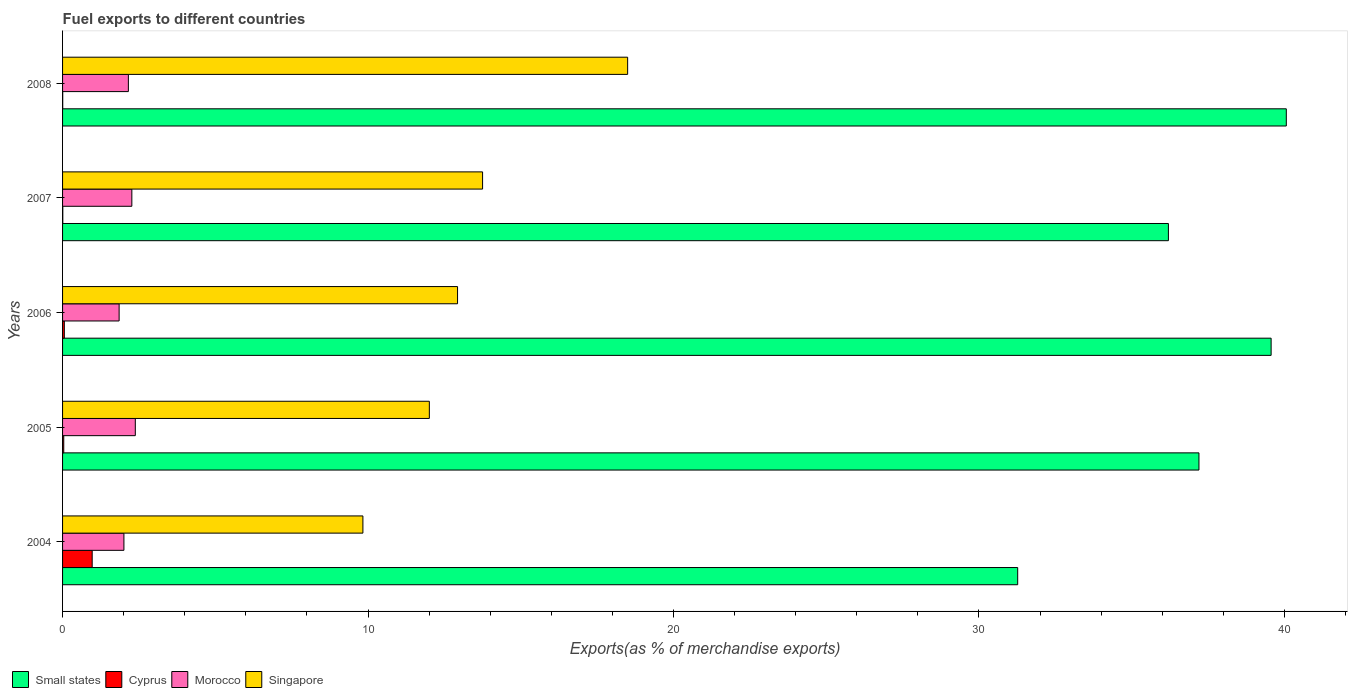How many bars are there on the 2nd tick from the top?
Offer a very short reply. 4. How many bars are there on the 5th tick from the bottom?
Make the answer very short. 4. In how many cases, is the number of bars for a given year not equal to the number of legend labels?
Your answer should be compact. 0. What is the percentage of exports to different countries in Singapore in 2006?
Provide a succinct answer. 12.93. Across all years, what is the maximum percentage of exports to different countries in Small states?
Give a very brief answer. 40.06. Across all years, what is the minimum percentage of exports to different countries in Cyprus?
Offer a terse response. 0. In which year was the percentage of exports to different countries in Morocco maximum?
Offer a terse response. 2005. What is the total percentage of exports to different countries in Cyprus in the graph?
Your answer should be very brief. 1.08. What is the difference between the percentage of exports to different countries in Morocco in 2004 and that in 2006?
Keep it short and to the point. 0.16. What is the difference between the percentage of exports to different countries in Cyprus in 2006 and the percentage of exports to different countries in Morocco in 2007?
Ensure brevity in your answer.  -2.21. What is the average percentage of exports to different countries in Cyprus per year?
Provide a short and direct response. 0.22. In the year 2006, what is the difference between the percentage of exports to different countries in Singapore and percentage of exports to different countries in Small states?
Your answer should be very brief. -26.63. In how many years, is the percentage of exports to different countries in Morocco greater than 38 %?
Give a very brief answer. 0. What is the ratio of the percentage of exports to different countries in Cyprus in 2004 to that in 2005?
Keep it short and to the point. 25.09. Is the difference between the percentage of exports to different countries in Singapore in 2004 and 2008 greater than the difference between the percentage of exports to different countries in Small states in 2004 and 2008?
Ensure brevity in your answer.  Yes. What is the difference between the highest and the second highest percentage of exports to different countries in Morocco?
Your response must be concise. 0.11. What is the difference between the highest and the lowest percentage of exports to different countries in Small states?
Provide a short and direct response. 8.79. In how many years, is the percentage of exports to different countries in Singapore greater than the average percentage of exports to different countries in Singapore taken over all years?
Give a very brief answer. 2. Is the sum of the percentage of exports to different countries in Small states in 2006 and 2007 greater than the maximum percentage of exports to different countries in Singapore across all years?
Give a very brief answer. Yes. Is it the case that in every year, the sum of the percentage of exports to different countries in Morocco and percentage of exports to different countries in Cyprus is greater than the sum of percentage of exports to different countries in Small states and percentage of exports to different countries in Singapore?
Offer a terse response. No. What does the 3rd bar from the top in 2006 represents?
Offer a terse response. Cyprus. What does the 2nd bar from the bottom in 2005 represents?
Offer a terse response. Cyprus. How many bars are there?
Keep it short and to the point. 20. Are the values on the major ticks of X-axis written in scientific E-notation?
Your answer should be compact. No. Where does the legend appear in the graph?
Make the answer very short. Bottom left. How many legend labels are there?
Provide a succinct answer. 4. What is the title of the graph?
Keep it short and to the point. Fuel exports to different countries. Does "Heavily indebted poor countries" appear as one of the legend labels in the graph?
Your answer should be compact. No. What is the label or title of the X-axis?
Offer a terse response. Exports(as % of merchandise exports). What is the label or title of the Y-axis?
Offer a very short reply. Years. What is the Exports(as % of merchandise exports) of Small states in 2004?
Provide a short and direct response. 31.27. What is the Exports(as % of merchandise exports) in Cyprus in 2004?
Your answer should be compact. 0.97. What is the Exports(as % of merchandise exports) in Morocco in 2004?
Provide a succinct answer. 2.01. What is the Exports(as % of merchandise exports) in Singapore in 2004?
Make the answer very short. 9.83. What is the Exports(as % of merchandise exports) in Small states in 2005?
Your answer should be very brief. 37.2. What is the Exports(as % of merchandise exports) of Cyprus in 2005?
Your answer should be very brief. 0.04. What is the Exports(as % of merchandise exports) of Morocco in 2005?
Your response must be concise. 2.38. What is the Exports(as % of merchandise exports) in Singapore in 2005?
Your answer should be compact. 12.01. What is the Exports(as % of merchandise exports) in Small states in 2006?
Your answer should be very brief. 39.56. What is the Exports(as % of merchandise exports) of Cyprus in 2006?
Provide a succinct answer. 0.06. What is the Exports(as % of merchandise exports) in Morocco in 2006?
Ensure brevity in your answer.  1.85. What is the Exports(as % of merchandise exports) in Singapore in 2006?
Your answer should be compact. 12.93. What is the Exports(as % of merchandise exports) of Small states in 2007?
Keep it short and to the point. 36.2. What is the Exports(as % of merchandise exports) in Cyprus in 2007?
Offer a very short reply. 0.01. What is the Exports(as % of merchandise exports) of Morocco in 2007?
Provide a succinct answer. 2.27. What is the Exports(as % of merchandise exports) of Singapore in 2007?
Ensure brevity in your answer.  13.75. What is the Exports(as % of merchandise exports) in Small states in 2008?
Your answer should be very brief. 40.06. What is the Exports(as % of merchandise exports) in Cyprus in 2008?
Your response must be concise. 0. What is the Exports(as % of merchandise exports) of Morocco in 2008?
Provide a short and direct response. 2.15. What is the Exports(as % of merchandise exports) of Singapore in 2008?
Provide a succinct answer. 18.5. Across all years, what is the maximum Exports(as % of merchandise exports) in Small states?
Your response must be concise. 40.06. Across all years, what is the maximum Exports(as % of merchandise exports) of Cyprus?
Make the answer very short. 0.97. Across all years, what is the maximum Exports(as % of merchandise exports) in Morocco?
Provide a short and direct response. 2.38. Across all years, what is the maximum Exports(as % of merchandise exports) of Singapore?
Provide a succinct answer. 18.5. Across all years, what is the minimum Exports(as % of merchandise exports) in Small states?
Your answer should be compact. 31.27. Across all years, what is the minimum Exports(as % of merchandise exports) of Cyprus?
Make the answer very short. 0. Across all years, what is the minimum Exports(as % of merchandise exports) in Morocco?
Keep it short and to the point. 1.85. Across all years, what is the minimum Exports(as % of merchandise exports) of Singapore?
Offer a very short reply. 9.83. What is the total Exports(as % of merchandise exports) of Small states in the graph?
Make the answer very short. 184.29. What is the total Exports(as % of merchandise exports) of Cyprus in the graph?
Offer a very short reply. 1.08. What is the total Exports(as % of merchandise exports) in Morocco in the graph?
Offer a terse response. 10.66. What is the total Exports(as % of merchandise exports) of Singapore in the graph?
Provide a succinct answer. 67.02. What is the difference between the Exports(as % of merchandise exports) of Small states in 2004 and that in 2005?
Provide a succinct answer. -5.93. What is the difference between the Exports(as % of merchandise exports) in Morocco in 2004 and that in 2005?
Your answer should be very brief. -0.37. What is the difference between the Exports(as % of merchandise exports) in Singapore in 2004 and that in 2005?
Your response must be concise. -2.17. What is the difference between the Exports(as % of merchandise exports) of Small states in 2004 and that in 2006?
Your answer should be compact. -8.3. What is the difference between the Exports(as % of merchandise exports) in Cyprus in 2004 and that in 2006?
Your answer should be compact. 0.91. What is the difference between the Exports(as % of merchandise exports) of Morocco in 2004 and that in 2006?
Provide a succinct answer. 0.16. What is the difference between the Exports(as % of merchandise exports) of Singapore in 2004 and that in 2006?
Provide a short and direct response. -3.1. What is the difference between the Exports(as % of merchandise exports) of Small states in 2004 and that in 2007?
Your response must be concise. -4.93. What is the difference between the Exports(as % of merchandise exports) in Cyprus in 2004 and that in 2007?
Provide a succinct answer. 0.96. What is the difference between the Exports(as % of merchandise exports) of Morocco in 2004 and that in 2007?
Your answer should be compact. -0.26. What is the difference between the Exports(as % of merchandise exports) in Singapore in 2004 and that in 2007?
Give a very brief answer. -3.92. What is the difference between the Exports(as % of merchandise exports) of Small states in 2004 and that in 2008?
Provide a succinct answer. -8.79. What is the difference between the Exports(as % of merchandise exports) of Cyprus in 2004 and that in 2008?
Keep it short and to the point. 0.96. What is the difference between the Exports(as % of merchandise exports) of Morocco in 2004 and that in 2008?
Provide a short and direct response. -0.15. What is the difference between the Exports(as % of merchandise exports) of Singapore in 2004 and that in 2008?
Your response must be concise. -8.67. What is the difference between the Exports(as % of merchandise exports) of Small states in 2005 and that in 2006?
Offer a terse response. -2.36. What is the difference between the Exports(as % of merchandise exports) in Cyprus in 2005 and that in 2006?
Provide a succinct answer. -0.02. What is the difference between the Exports(as % of merchandise exports) of Morocco in 2005 and that in 2006?
Keep it short and to the point. 0.53. What is the difference between the Exports(as % of merchandise exports) of Singapore in 2005 and that in 2006?
Ensure brevity in your answer.  -0.92. What is the difference between the Exports(as % of merchandise exports) in Small states in 2005 and that in 2007?
Offer a very short reply. 1. What is the difference between the Exports(as % of merchandise exports) of Cyprus in 2005 and that in 2007?
Provide a succinct answer. 0.03. What is the difference between the Exports(as % of merchandise exports) in Morocco in 2005 and that in 2007?
Your answer should be very brief. 0.11. What is the difference between the Exports(as % of merchandise exports) in Singapore in 2005 and that in 2007?
Ensure brevity in your answer.  -1.74. What is the difference between the Exports(as % of merchandise exports) of Small states in 2005 and that in 2008?
Keep it short and to the point. -2.86. What is the difference between the Exports(as % of merchandise exports) of Cyprus in 2005 and that in 2008?
Your answer should be compact. 0.03. What is the difference between the Exports(as % of merchandise exports) of Morocco in 2005 and that in 2008?
Your response must be concise. 0.23. What is the difference between the Exports(as % of merchandise exports) in Singapore in 2005 and that in 2008?
Your answer should be compact. -6.49. What is the difference between the Exports(as % of merchandise exports) of Small states in 2006 and that in 2007?
Make the answer very short. 3.36. What is the difference between the Exports(as % of merchandise exports) of Cyprus in 2006 and that in 2007?
Ensure brevity in your answer.  0.05. What is the difference between the Exports(as % of merchandise exports) in Morocco in 2006 and that in 2007?
Your answer should be very brief. -0.42. What is the difference between the Exports(as % of merchandise exports) in Singapore in 2006 and that in 2007?
Offer a very short reply. -0.82. What is the difference between the Exports(as % of merchandise exports) of Small states in 2006 and that in 2008?
Give a very brief answer. -0.5. What is the difference between the Exports(as % of merchandise exports) in Cyprus in 2006 and that in 2008?
Give a very brief answer. 0.05. What is the difference between the Exports(as % of merchandise exports) in Morocco in 2006 and that in 2008?
Make the answer very short. -0.3. What is the difference between the Exports(as % of merchandise exports) of Singapore in 2006 and that in 2008?
Your answer should be compact. -5.57. What is the difference between the Exports(as % of merchandise exports) of Small states in 2007 and that in 2008?
Provide a short and direct response. -3.86. What is the difference between the Exports(as % of merchandise exports) in Cyprus in 2007 and that in 2008?
Ensure brevity in your answer.  0. What is the difference between the Exports(as % of merchandise exports) in Morocco in 2007 and that in 2008?
Provide a short and direct response. 0.11. What is the difference between the Exports(as % of merchandise exports) of Singapore in 2007 and that in 2008?
Your answer should be very brief. -4.75. What is the difference between the Exports(as % of merchandise exports) in Small states in 2004 and the Exports(as % of merchandise exports) in Cyprus in 2005?
Ensure brevity in your answer.  31.23. What is the difference between the Exports(as % of merchandise exports) of Small states in 2004 and the Exports(as % of merchandise exports) of Morocco in 2005?
Provide a short and direct response. 28.89. What is the difference between the Exports(as % of merchandise exports) of Small states in 2004 and the Exports(as % of merchandise exports) of Singapore in 2005?
Ensure brevity in your answer.  19.26. What is the difference between the Exports(as % of merchandise exports) in Cyprus in 2004 and the Exports(as % of merchandise exports) in Morocco in 2005?
Make the answer very short. -1.41. What is the difference between the Exports(as % of merchandise exports) of Cyprus in 2004 and the Exports(as % of merchandise exports) of Singapore in 2005?
Your answer should be compact. -11.04. What is the difference between the Exports(as % of merchandise exports) in Morocco in 2004 and the Exports(as % of merchandise exports) in Singapore in 2005?
Make the answer very short. -10. What is the difference between the Exports(as % of merchandise exports) in Small states in 2004 and the Exports(as % of merchandise exports) in Cyprus in 2006?
Your response must be concise. 31.21. What is the difference between the Exports(as % of merchandise exports) in Small states in 2004 and the Exports(as % of merchandise exports) in Morocco in 2006?
Make the answer very short. 29.42. What is the difference between the Exports(as % of merchandise exports) of Small states in 2004 and the Exports(as % of merchandise exports) of Singapore in 2006?
Ensure brevity in your answer.  18.34. What is the difference between the Exports(as % of merchandise exports) in Cyprus in 2004 and the Exports(as % of merchandise exports) in Morocco in 2006?
Your answer should be very brief. -0.88. What is the difference between the Exports(as % of merchandise exports) in Cyprus in 2004 and the Exports(as % of merchandise exports) in Singapore in 2006?
Your answer should be very brief. -11.96. What is the difference between the Exports(as % of merchandise exports) in Morocco in 2004 and the Exports(as % of merchandise exports) in Singapore in 2006?
Your answer should be compact. -10.92. What is the difference between the Exports(as % of merchandise exports) in Small states in 2004 and the Exports(as % of merchandise exports) in Cyprus in 2007?
Keep it short and to the point. 31.26. What is the difference between the Exports(as % of merchandise exports) of Small states in 2004 and the Exports(as % of merchandise exports) of Morocco in 2007?
Offer a very short reply. 29. What is the difference between the Exports(as % of merchandise exports) of Small states in 2004 and the Exports(as % of merchandise exports) of Singapore in 2007?
Keep it short and to the point. 17.52. What is the difference between the Exports(as % of merchandise exports) of Cyprus in 2004 and the Exports(as % of merchandise exports) of Morocco in 2007?
Provide a short and direct response. -1.3. What is the difference between the Exports(as % of merchandise exports) in Cyprus in 2004 and the Exports(as % of merchandise exports) in Singapore in 2007?
Ensure brevity in your answer.  -12.78. What is the difference between the Exports(as % of merchandise exports) in Morocco in 2004 and the Exports(as % of merchandise exports) in Singapore in 2007?
Your answer should be compact. -11.74. What is the difference between the Exports(as % of merchandise exports) of Small states in 2004 and the Exports(as % of merchandise exports) of Cyprus in 2008?
Your response must be concise. 31.26. What is the difference between the Exports(as % of merchandise exports) of Small states in 2004 and the Exports(as % of merchandise exports) of Morocco in 2008?
Your answer should be compact. 29.11. What is the difference between the Exports(as % of merchandise exports) in Small states in 2004 and the Exports(as % of merchandise exports) in Singapore in 2008?
Keep it short and to the point. 12.77. What is the difference between the Exports(as % of merchandise exports) of Cyprus in 2004 and the Exports(as % of merchandise exports) of Morocco in 2008?
Ensure brevity in your answer.  -1.18. What is the difference between the Exports(as % of merchandise exports) of Cyprus in 2004 and the Exports(as % of merchandise exports) of Singapore in 2008?
Your answer should be compact. -17.53. What is the difference between the Exports(as % of merchandise exports) in Morocco in 2004 and the Exports(as % of merchandise exports) in Singapore in 2008?
Your answer should be very brief. -16.49. What is the difference between the Exports(as % of merchandise exports) of Small states in 2005 and the Exports(as % of merchandise exports) of Cyprus in 2006?
Your answer should be compact. 37.14. What is the difference between the Exports(as % of merchandise exports) in Small states in 2005 and the Exports(as % of merchandise exports) in Morocco in 2006?
Offer a terse response. 35.35. What is the difference between the Exports(as % of merchandise exports) of Small states in 2005 and the Exports(as % of merchandise exports) of Singapore in 2006?
Keep it short and to the point. 24.27. What is the difference between the Exports(as % of merchandise exports) of Cyprus in 2005 and the Exports(as % of merchandise exports) of Morocco in 2006?
Make the answer very short. -1.81. What is the difference between the Exports(as % of merchandise exports) in Cyprus in 2005 and the Exports(as % of merchandise exports) in Singapore in 2006?
Give a very brief answer. -12.89. What is the difference between the Exports(as % of merchandise exports) of Morocco in 2005 and the Exports(as % of merchandise exports) of Singapore in 2006?
Offer a terse response. -10.55. What is the difference between the Exports(as % of merchandise exports) of Small states in 2005 and the Exports(as % of merchandise exports) of Cyprus in 2007?
Keep it short and to the point. 37.19. What is the difference between the Exports(as % of merchandise exports) of Small states in 2005 and the Exports(as % of merchandise exports) of Morocco in 2007?
Your response must be concise. 34.93. What is the difference between the Exports(as % of merchandise exports) in Small states in 2005 and the Exports(as % of merchandise exports) in Singapore in 2007?
Offer a very short reply. 23.45. What is the difference between the Exports(as % of merchandise exports) in Cyprus in 2005 and the Exports(as % of merchandise exports) in Morocco in 2007?
Make the answer very short. -2.23. What is the difference between the Exports(as % of merchandise exports) of Cyprus in 2005 and the Exports(as % of merchandise exports) of Singapore in 2007?
Offer a terse response. -13.71. What is the difference between the Exports(as % of merchandise exports) of Morocco in 2005 and the Exports(as % of merchandise exports) of Singapore in 2007?
Offer a very short reply. -11.37. What is the difference between the Exports(as % of merchandise exports) in Small states in 2005 and the Exports(as % of merchandise exports) in Cyprus in 2008?
Offer a terse response. 37.2. What is the difference between the Exports(as % of merchandise exports) in Small states in 2005 and the Exports(as % of merchandise exports) in Morocco in 2008?
Provide a short and direct response. 35.05. What is the difference between the Exports(as % of merchandise exports) of Small states in 2005 and the Exports(as % of merchandise exports) of Singapore in 2008?
Give a very brief answer. 18.7. What is the difference between the Exports(as % of merchandise exports) in Cyprus in 2005 and the Exports(as % of merchandise exports) in Morocco in 2008?
Make the answer very short. -2.12. What is the difference between the Exports(as % of merchandise exports) of Cyprus in 2005 and the Exports(as % of merchandise exports) of Singapore in 2008?
Ensure brevity in your answer.  -18.46. What is the difference between the Exports(as % of merchandise exports) of Morocco in 2005 and the Exports(as % of merchandise exports) of Singapore in 2008?
Make the answer very short. -16.12. What is the difference between the Exports(as % of merchandise exports) in Small states in 2006 and the Exports(as % of merchandise exports) in Cyprus in 2007?
Make the answer very short. 39.56. What is the difference between the Exports(as % of merchandise exports) of Small states in 2006 and the Exports(as % of merchandise exports) of Morocco in 2007?
Provide a succinct answer. 37.3. What is the difference between the Exports(as % of merchandise exports) of Small states in 2006 and the Exports(as % of merchandise exports) of Singapore in 2007?
Give a very brief answer. 25.81. What is the difference between the Exports(as % of merchandise exports) of Cyprus in 2006 and the Exports(as % of merchandise exports) of Morocco in 2007?
Make the answer very short. -2.21. What is the difference between the Exports(as % of merchandise exports) of Cyprus in 2006 and the Exports(as % of merchandise exports) of Singapore in 2007?
Make the answer very short. -13.69. What is the difference between the Exports(as % of merchandise exports) in Morocco in 2006 and the Exports(as % of merchandise exports) in Singapore in 2007?
Your answer should be very brief. -11.9. What is the difference between the Exports(as % of merchandise exports) of Small states in 2006 and the Exports(as % of merchandise exports) of Cyprus in 2008?
Provide a succinct answer. 39.56. What is the difference between the Exports(as % of merchandise exports) in Small states in 2006 and the Exports(as % of merchandise exports) in Morocco in 2008?
Ensure brevity in your answer.  37.41. What is the difference between the Exports(as % of merchandise exports) in Small states in 2006 and the Exports(as % of merchandise exports) in Singapore in 2008?
Offer a terse response. 21.07. What is the difference between the Exports(as % of merchandise exports) of Cyprus in 2006 and the Exports(as % of merchandise exports) of Morocco in 2008?
Your response must be concise. -2.1. What is the difference between the Exports(as % of merchandise exports) of Cyprus in 2006 and the Exports(as % of merchandise exports) of Singapore in 2008?
Your answer should be compact. -18.44. What is the difference between the Exports(as % of merchandise exports) of Morocco in 2006 and the Exports(as % of merchandise exports) of Singapore in 2008?
Offer a very short reply. -16.65. What is the difference between the Exports(as % of merchandise exports) in Small states in 2007 and the Exports(as % of merchandise exports) in Cyprus in 2008?
Provide a succinct answer. 36.2. What is the difference between the Exports(as % of merchandise exports) of Small states in 2007 and the Exports(as % of merchandise exports) of Morocco in 2008?
Keep it short and to the point. 34.05. What is the difference between the Exports(as % of merchandise exports) of Small states in 2007 and the Exports(as % of merchandise exports) of Singapore in 2008?
Make the answer very short. 17.7. What is the difference between the Exports(as % of merchandise exports) of Cyprus in 2007 and the Exports(as % of merchandise exports) of Morocco in 2008?
Give a very brief answer. -2.15. What is the difference between the Exports(as % of merchandise exports) in Cyprus in 2007 and the Exports(as % of merchandise exports) in Singapore in 2008?
Keep it short and to the point. -18.49. What is the difference between the Exports(as % of merchandise exports) in Morocco in 2007 and the Exports(as % of merchandise exports) in Singapore in 2008?
Your answer should be compact. -16.23. What is the average Exports(as % of merchandise exports) of Small states per year?
Keep it short and to the point. 36.86. What is the average Exports(as % of merchandise exports) in Cyprus per year?
Offer a terse response. 0.22. What is the average Exports(as % of merchandise exports) of Morocco per year?
Keep it short and to the point. 2.13. What is the average Exports(as % of merchandise exports) in Singapore per year?
Your response must be concise. 13.4. In the year 2004, what is the difference between the Exports(as % of merchandise exports) of Small states and Exports(as % of merchandise exports) of Cyprus?
Your answer should be compact. 30.3. In the year 2004, what is the difference between the Exports(as % of merchandise exports) in Small states and Exports(as % of merchandise exports) in Morocco?
Your answer should be compact. 29.26. In the year 2004, what is the difference between the Exports(as % of merchandise exports) in Small states and Exports(as % of merchandise exports) in Singapore?
Ensure brevity in your answer.  21.43. In the year 2004, what is the difference between the Exports(as % of merchandise exports) in Cyprus and Exports(as % of merchandise exports) in Morocco?
Provide a succinct answer. -1.04. In the year 2004, what is the difference between the Exports(as % of merchandise exports) of Cyprus and Exports(as % of merchandise exports) of Singapore?
Your answer should be compact. -8.86. In the year 2004, what is the difference between the Exports(as % of merchandise exports) in Morocco and Exports(as % of merchandise exports) in Singapore?
Ensure brevity in your answer.  -7.82. In the year 2005, what is the difference between the Exports(as % of merchandise exports) in Small states and Exports(as % of merchandise exports) in Cyprus?
Keep it short and to the point. 37.16. In the year 2005, what is the difference between the Exports(as % of merchandise exports) in Small states and Exports(as % of merchandise exports) in Morocco?
Offer a terse response. 34.82. In the year 2005, what is the difference between the Exports(as % of merchandise exports) of Small states and Exports(as % of merchandise exports) of Singapore?
Offer a terse response. 25.19. In the year 2005, what is the difference between the Exports(as % of merchandise exports) in Cyprus and Exports(as % of merchandise exports) in Morocco?
Keep it short and to the point. -2.34. In the year 2005, what is the difference between the Exports(as % of merchandise exports) in Cyprus and Exports(as % of merchandise exports) in Singapore?
Provide a short and direct response. -11.97. In the year 2005, what is the difference between the Exports(as % of merchandise exports) of Morocco and Exports(as % of merchandise exports) of Singapore?
Ensure brevity in your answer.  -9.63. In the year 2006, what is the difference between the Exports(as % of merchandise exports) of Small states and Exports(as % of merchandise exports) of Cyprus?
Your response must be concise. 39.51. In the year 2006, what is the difference between the Exports(as % of merchandise exports) in Small states and Exports(as % of merchandise exports) in Morocco?
Ensure brevity in your answer.  37.71. In the year 2006, what is the difference between the Exports(as % of merchandise exports) of Small states and Exports(as % of merchandise exports) of Singapore?
Offer a terse response. 26.63. In the year 2006, what is the difference between the Exports(as % of merchandise exports) in Cyprus and Exports(as % of merchandise exports) in Morocco?
Offer a terse response. -1.79. In the year 2006, what is the difference between the Exports(as % of merchandise exports) in Cyprus and Exports(as % of merchandise exports) in Singapore?
Your response must be concise. -12.87. In the year 2006, what is the difference between the Exports(as % of merchandise exports) in Morocco and Exports(as % of merchandise exports) in Singapore?
Ensure brevity in your answer.  -11.08. In the year 2007, what is the difference between the Exports(as % of merchandise exports) in Small states and Exports(as % of merchandise exports) in Cyprus?
Your answer should be very brief. 36.19. In the year 2007, what is the difference between the Exports(as % of merchandise exports) of Small states and Exports(as % of merchandise exports) of Morocco?
Offer a very short reply. 33.93. In the year 2007, what is the difference between the Exports(as % of merchandise exports) in Small states and Exports(as % of merchandise exports) in Singapore?
Keep it short and to the point. 22.45. In the year 2007, what is the difference between the Exports(as % of merchandise exports) of Cyprus and Exports(as % of merchandise exports) of Morocco?
Your response must be concise. -2.26. In the year 2007, what is the difference between the Exports(as % of merchandise exports) of Cyprus and Exports(as % of merchandise exports) of Singapore?
Keep it short and to the point. -13.74. In the year 2007, what is the difference between the Exports(as % of merchandise exports) of Morocco and Exports(as % of merchandise exports) of Singapore?
Offer a very short reply. -11.48. In the year 2008, what is the difference between the Exports(as % of merchandise exports) of Small states and Exports(as % of merchandise exports) of Cyprus?
Give a very brief answer. 40.06. In the year 2008, what is the difference between the Exports(as % of merchandise exports) in Small states and Exports(as % of merchandise exports) in Morocco?
Ensure brevity in your answer.  37.91. In the year 2008, what is the difference between the Exports(as % of merchandise exports) in Small states and Exports(as % of merchandise exports) in Singapore?
Your answer should be compact. 21.56. In the year 2008, what is the difference between the Exports(as % of merchandise exports) of Cyprus and Exports(as % of merchandise exports) of Morocco?
Your answer should be compact. -2.15. In the year 2008, what is the difference between the Exports(as % of merchandise exports) in Cyprus and Exports(as % of merchandise exports) in Singapore?
Your answer should be compact. -18.49. In the year 2008, what is the difference between the Exports(as % of merchandise exports) of Morocco and Exports(as % of merchandise exports) of Singapore?
Make the answer very short. -16.34. What is the ratio of the Exports(as % of merchandise exports) of Small states in 2004 to that in 2005?
Ensure brevity in your answer.  0.84. What is the ratio of the Exports(as % of merchandise exports) of Cyprus in 2004 to that in 2005?
Offer a terse response. 25.09. What is the ratio of the Exports(as % of merchandise exports) of Morocco in 2004 to that in 2005?
Offer a terse response. 0.84. What is the ratio of the Exports(as % of merchandise exports) of Singapore in 2004 to that in 2005?
Your answer should be compact. 0.82. What is the ratio of the Exports(as % of merchandise exports) in Small states in 2004 to that in 2006?
Offer a terse response. 0.79. What is the ratio of the Exports(as % of merchandise exports) of Cyprus in 2004 to that in 2006?
Keep it short and to the point. 16.86. What is the ratio of the Exports(as % of merchandise exports) in Morocco in 2004 to that in 2006?
Keep it short and to the point. 1.08. What is the ratio of the Exports(as % of merchandise exports) of Singapore in 2004 to that in 2006?
Offer a very short reply. 0.76. What is the ratio of the Exports(as % of merchandise exports) in Small states in 2004 to that in 2007?
Keep it short and to the point. 0.86. What is the ratio of the Exports(as % of merchandise exports) of Cyprus in 2004 to that in 2007?
Your answer should be very brief. 127.06. What is the ratio of the Exports(as % of merchandise exports) in Morocco in 2004 to that in 2007?
Your answer should be compact. 0.89. What is the ratio of the Exports(as % of merchandise exports) in Singapore in 2004 to that in 2007?
Make the answer very short. 0.72. What is the ratio of the Exports(as % of merchandise exports) in Small states in 2004 to that in 2008?
Keep it short and to the point. 0.78. What is the ratio of the Exports(as % of merchandise exports) in Cyprus in 2004 to that in 2008?
Your response must be concise. 200.22. What is the ratio of the Exports(as % of merchandise exports) in Morocco in 2004 to that in 2008?
Offer a terse response. 0.93. What is the ratio of the Exports(as % of merchandise exports) in Singapore in 2004 to that in 2008?
Keep it short and to the point. 0.53. What is the ratio of the Exports(as % of merchandise exports) of Small states in 2005 to that in 2006?
Offer a terse response. 0.94. What is the ratio of the Exports(as % of merchandise exports) of Cyprus in 2005 to that in 2006?
Keep it short and to the point. 0.67. What is the ratio of the Exports(as % of merchandise exports) in Morocco in 2005 to that in 2006?
Keep it short and to the point. 1.29. What is the ratio of the Exports(as % of merchandise exports) of Singapore in 2005 to that in 2006?
Offer a terse response. 0.93. What is the ratio of the Exports(as % of merchandise exports) of Small states in 2005 to that in 2007?
Keep it short and to the point. 1.03. What is the ratio of the Exports(as % of merchandise exports) of Cyprus in 2005 to that in 2007?
Provide a short and direct response. 5.06. What is the ratio of the Exports(as % of merchandise exports) of Morocco in 2005 to that in 2007?
Your answer should be compact. 1.05. What is the ratio of the Exports(as % of merchandise exports) in Singapore in 2005 to that in 2007?
Offer a terse response. 0.87. What is the ratio of the Exports(as % of merchandise exports) in Small states in 2005 to that in 2008?
Your response must be concise. 0.93. What is the ratio of the Exports(as % of merchandise exports) in Cyprus in 2005 to that in 2008?
Provide a succinct answer. 7.98. What is the ratio of the Exports(as % of merchandise exports) in Morocco in 2005 to that in 2008?
Your answer should be very brief. 1.11. What is the ratio of the Exports(as % of merchandise exports) in Singapore in 2005 to that in 2008?
Keep it short and to the point. 0.65. What is the ratio of the Exports(as % of merchandise exports) of Small states in 2006 to that in 2007?
Offer a terse response. 1.09. What is the ratio of the Exports(as % of merchandise exports) of Cyprus in 2006 to that in 2007?
Keep it short and to the point. 7.54. What is the ratio of the Exports(as % of merchandise exports) of Morocco in 2006 to that in 2007?
Your answer should be compact. 0.82. What is the ratio of the Exports(as % of merchandise exports) in Singapore in 2006 to that in 2007?
Offer a very short reply. 0.94. What is the ratio of the Exports(as % of merchandise exports) in Small states in 2006 to that in 2008?
Your answer should be compact. 0.99. What is the ratio of the Exports(as % of merchandise exports) of Cyprus in 2006 to that in 2008?
Your answer should be compact. 11.87. What is the ratio of the Exports(as % of merchandise exports) of Morocco in 2006 to that in 2008?
Make the answer very short. 0.86. What is the ratio of the Exports(as % of merchandise exports) in Singapore in 2006 to that in 2008?
Make the answer very short. 0.7. What is the ratio of the Exports(as % of merchandise exports) in Small states in 2007 to that in 2008?
Provide a short and direct response. 0.9. What is the ratio of the Exports(as % of merchandise exports) of Cyprus in 2007 to that in 2008?
Provide a short and direct response. 1.58. What is the ratio of the Exports(as % of merchandise exports) in Morocco in 2007 to that in 2008?
Your answer should be very brief. 1.05. What is the ratio of the Exports(as % of merchandise exports) of Singapore in 2007 to that in 2008?
Ensure brevity in your answer.  0.74. What is the difference between the highest and the second highest Exports(as % of merchandise exports) of Small states?
Ensure brevity in your answer.  0.5. What is the difference between the highest and the second highest Exports(as % of merchandise exports) of Cyprus?
Keep it short and to the point. 0.91. What is the difference between the highest and the second highest Exports(as % of merchandise exports) in Morocco?
Ensure brevity in your answer.  0.11. What is the difference between the highest and the second highest Exports(as % of merchandise exports) of Singapore?
Your answer should be compact. 4.75. What is the difference between the highest and the lowest Exports(as % of merchandise exports) of Small states?
Give a very brief answer. 8.79. What is the difference between the highest and the lowest Exports(as % of merchandise exports) of Cyprus?
Your answer should be compact. 0.96. What is the difference between the highest and the lowest Exports(as % of merchandise exports) of Morocco?
Your response must be concise. 0.53. What is the difference between the highest and the lowest Exports(as % of merchandise exports) in Singapore?
Keep it short and to the point. 8.67. 